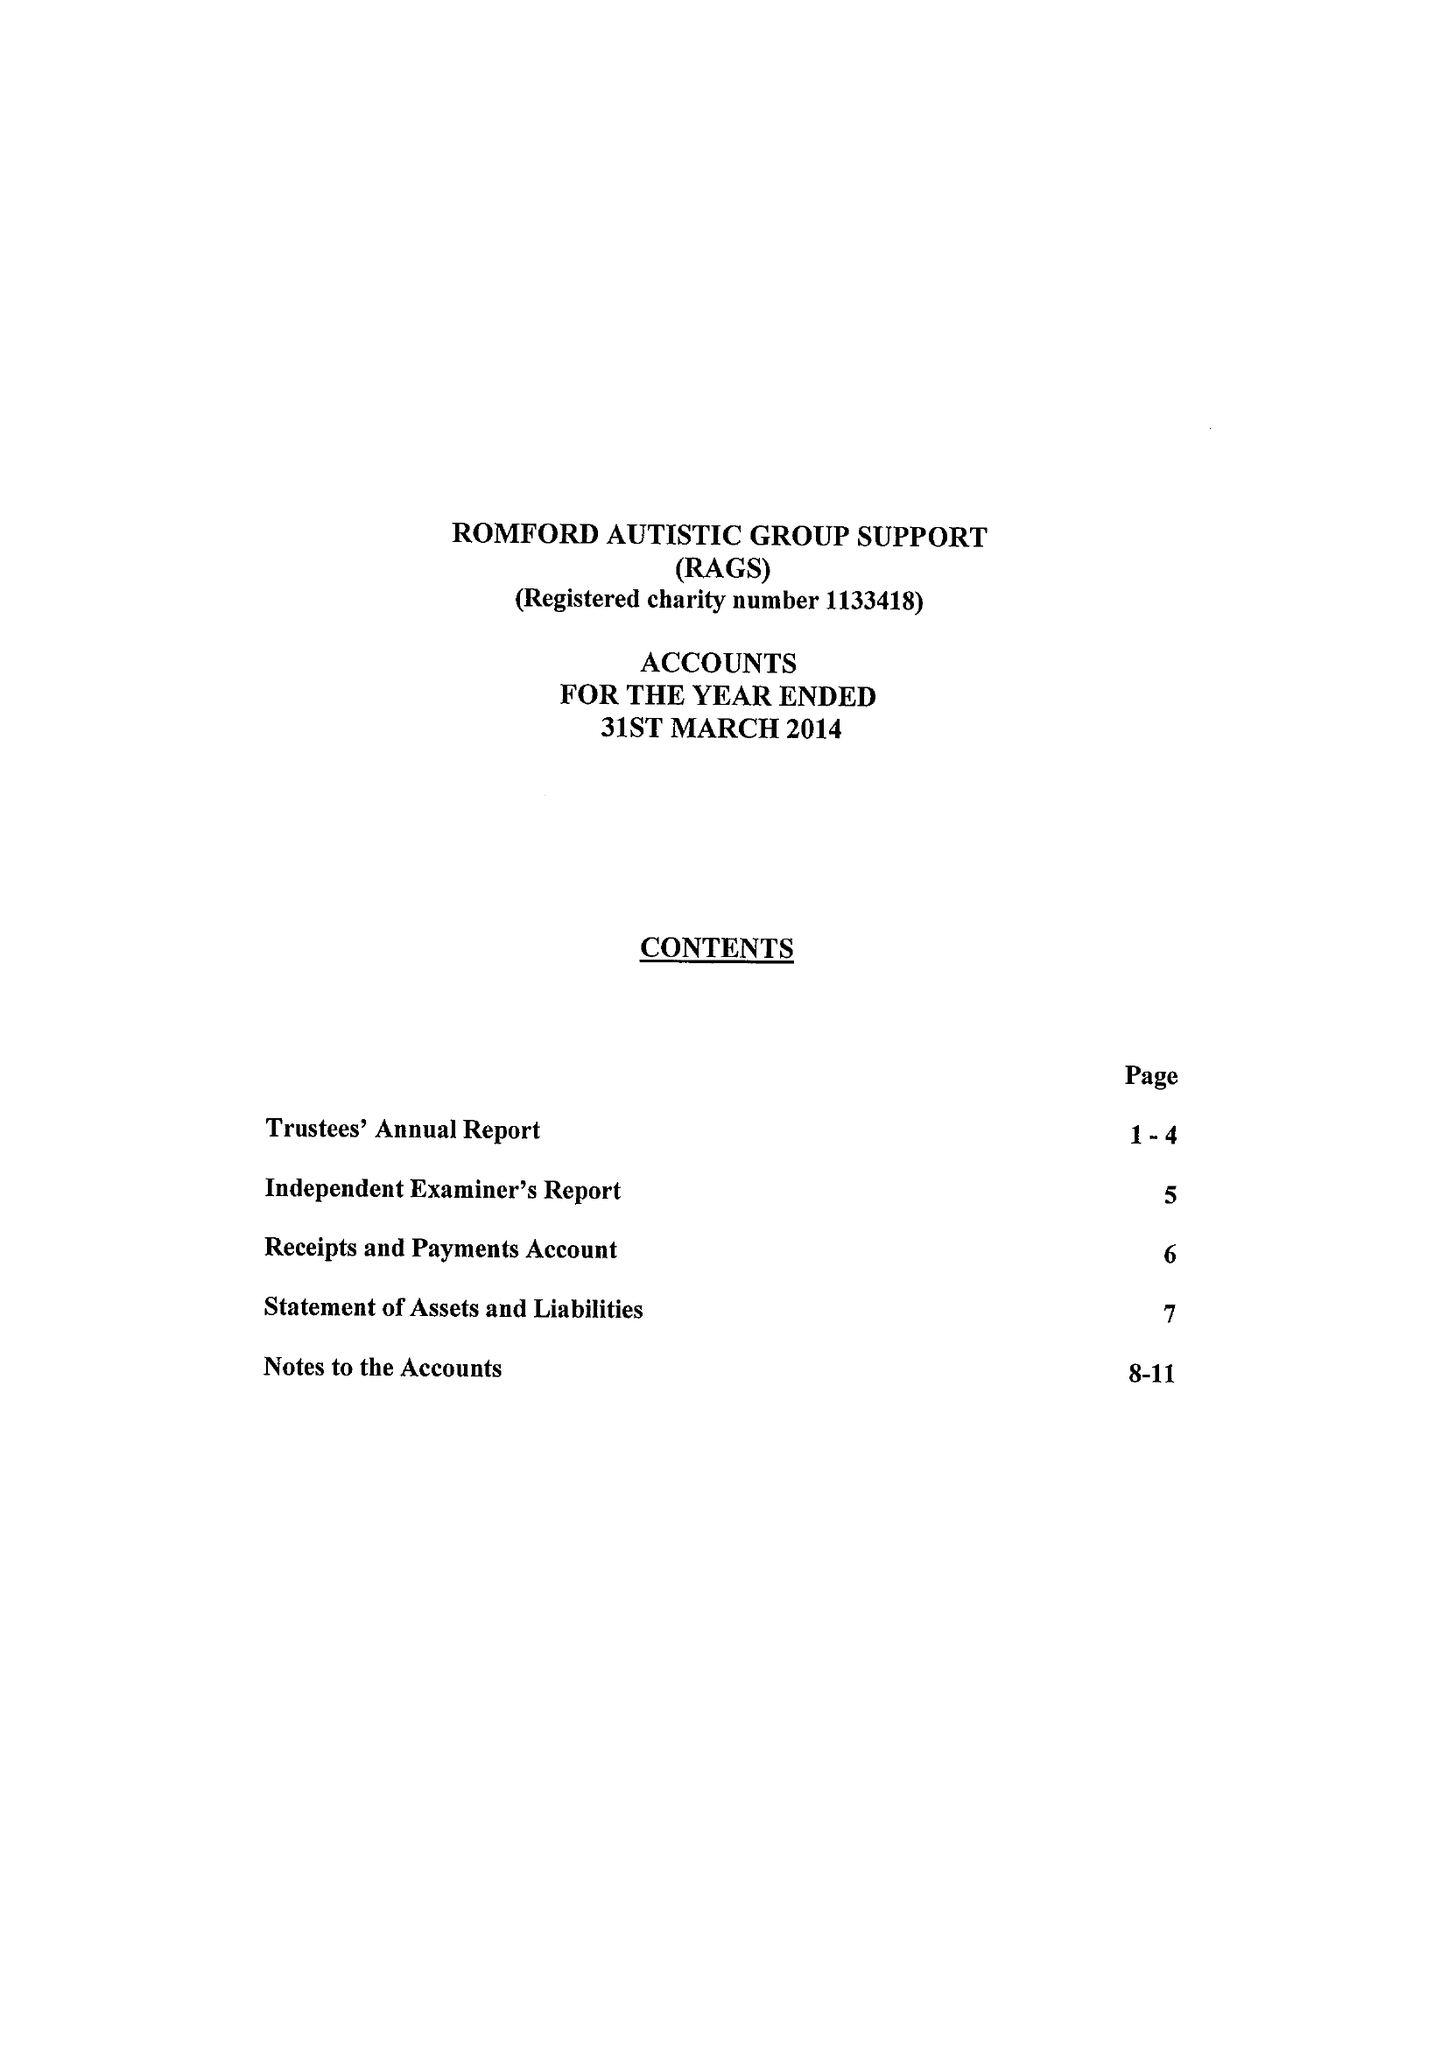What is the value for the report_date?
Answer the question using a single word or phrase. 2014-03-31 